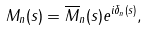Convert formula to latex. <formula><loc_0><loc_0><loc_500><loc_500>M _ { n } ( s ) = \overline { M } _ { n } ( s ) e ^ { i \delta _ { n } ( s ) } ,</formula> 